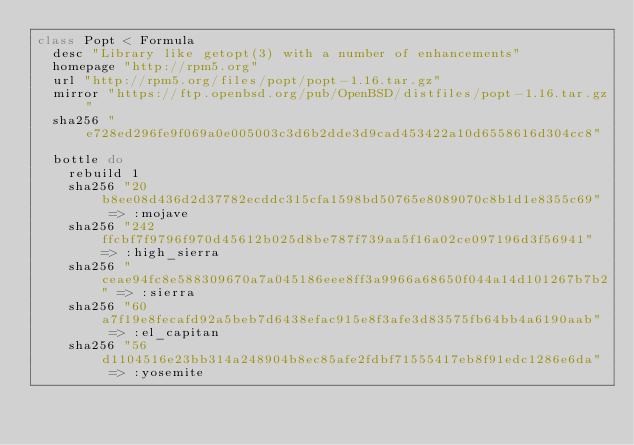Convert code to text. <code><loc_0><loc_0><loc_500><loc_500><_Ruby_>class Popt < Formula
  desc "Library like getopt(3) with a number of enhancements"
  homepage "http://rpm5.org"
  url "http://rpm5.org/files/popt/popt-1.16.tar.gz"
  mirror "https://ftp.openbsd.org/pub/OpenBSD/distfiles/popt-1.16.tar.gz"
  sha256 "e728ed296fe9f069a0e005003c3d6b2dde3d9cad453422a10d6558616d304cc8"

  bottle do
    rebuild 1
    sha256 "20b8ee08d436d2d37782ecddc315cfa1598bd50765e8089070c8b1d1e8355c69" => :mojave
    sha256 "242ffcbf7f9796f970d45612b025d8be787f739aa5f16a02ce097196d3f56941" => :high_sierra
    sha256 "ceae94fc8e588309670a7a045186eee8ff3a9966a68650f044a14d101267b7b2" => :sierra
    sha256 "60a7f19e8fecafd92a5beb7d6438efac915e8f3afe3d83575fb64bb4a6190aab" => :el_capitan
    sha256 "56d1104516e23bb314a248904b8ec85afe2fdbf71555417eb8f91edc1286e6da" => :yosemite</code> 